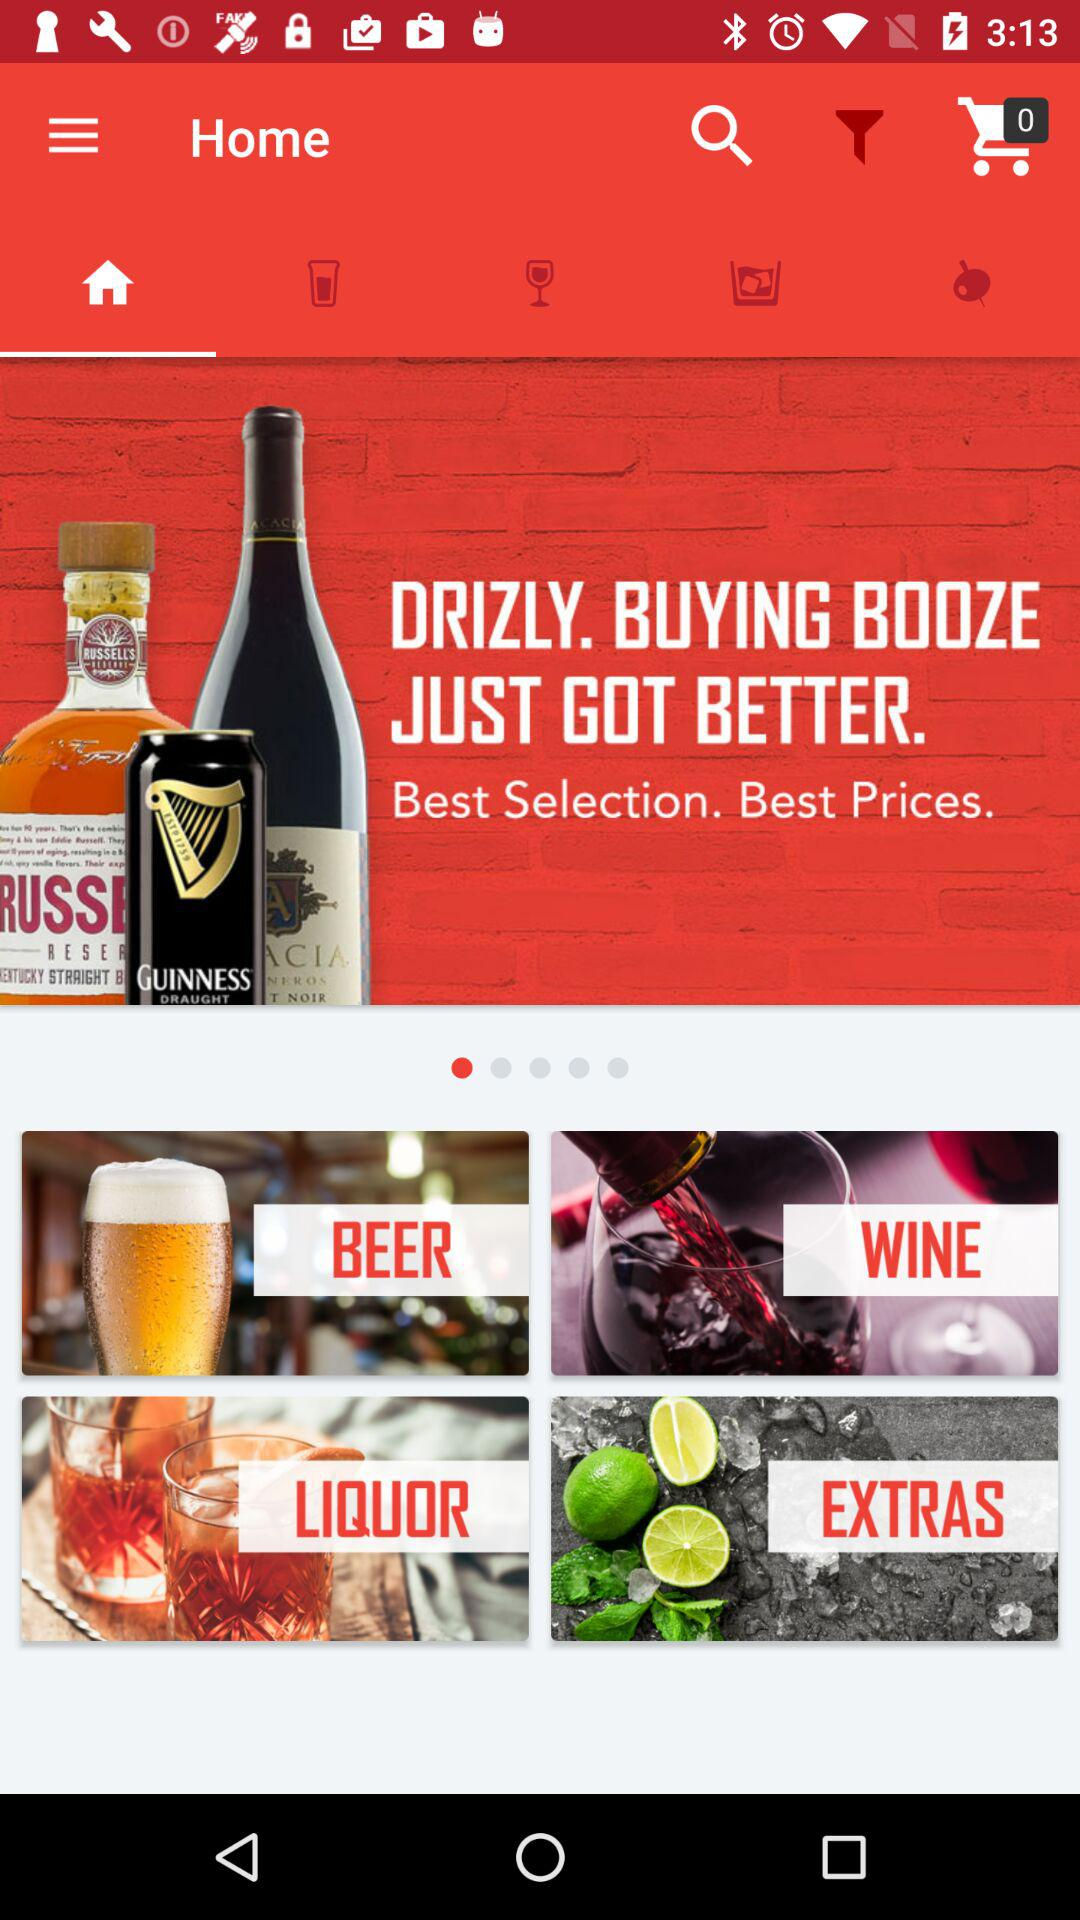How many items are in the shopping cart? There are 0 items in the shopping cart. 